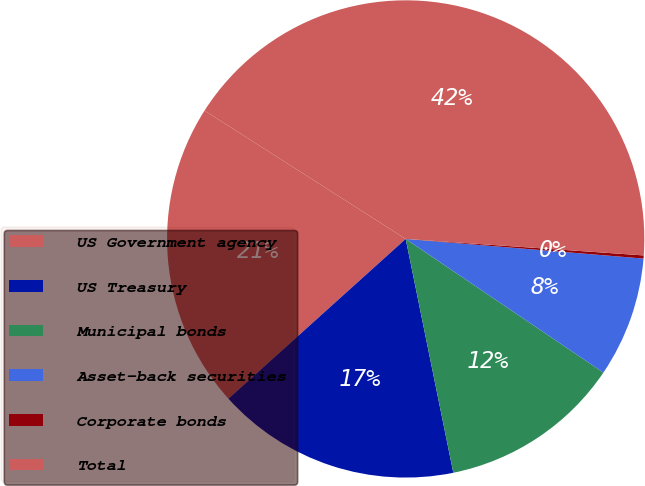Convert chart. <chart><loc_0><loc_0><loc_500><loc_500><pie_chart><fcel>US Government agency<fcel>US Treasury<fcel>Municipal bonds<fcel>Asset-back securities<fcel>Corporate bonds<fcel>Total<nl><fcel>20.71%<fcel>16.52%<fcel>12.34%<fcel>8.15%<fcel>0.21%<fcel>42.06%<nl></chart> 